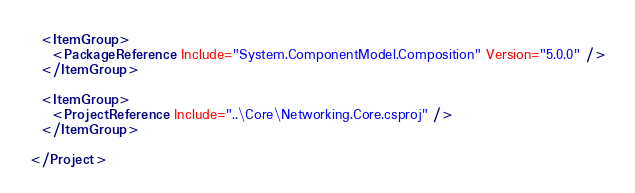<code> <loc_0><loc_0><loc_500><loc_500><_XML_>  <ItemGroup>
    <PackageReference Include="System.ComponentModel.Composition" Version="5.0.0" />
  </ItemGroup>

  <ItemGroup>
    <ProjectReference Include="..\Core\Networking.Core.csproj" />
  </ItemGroup>

</Project>
</code> 